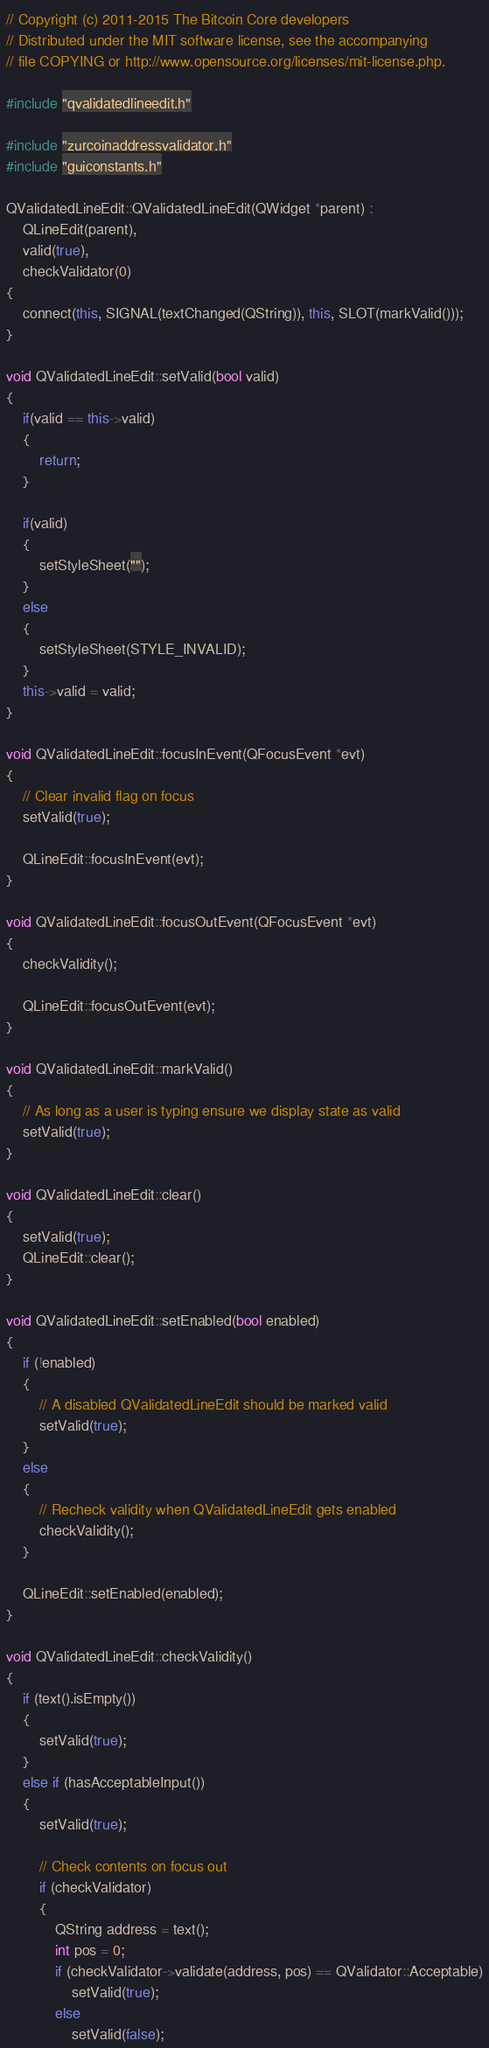Convert code to text. <code><loc_0><loc_0><loc_500><loc_500><_C++_>// Copyright (c) 2011-2015 The Bitcoin Core developers
// Distributed under the MIT software license, see the accompanying
// file COPYING or http://www.opensource.org/licenses/mit-license.php.

#include "qvalidatedlineedit.h"

#include "zurcoinaddressvalidator.h"
#include "guiconstants.h"

QValidatedLineEdit::QValidatedLineEdit(QWidget *parent) :
    QLineEdit(parent),
    valid(true),
    checkValidator(0)
{
    connect(this, SIGNAL(textChanged(QString)), this, SLOT(markValid()));
}

void QValidatedLineEdit::setValid(bool valid)
{
    if(valid == this->valid)
    {
        return;
    }

    if(valid)
    {
        setStyleSheet("");
    }
    else
    {
        setStyleSheet(STYLE_INVALID);
    }
    this->valid = valid;
}

void QValidatedLineEdit::focusInEvent(QFocusEvent *evt)
{
    // Clear invalid flag on focus
    setValid(true);

    QLineEdit::focusInEvent(evt);
}

void QValidatedLineEdit::focusOutEvent(QFocusEvent *evt)
{
    checkValidity();

    QLineEdit::focusOutEvent(evt);
}

void QValidatedLineEdit::markValid()
{
    // As long as a user is typing ensure we display state as valid
    setValid(true);
}

void QValidatedLineEdit::clear()
{
    setValid(true);
    QLineEdit::clear();
}

void QValidatedLineEdit::setEnabled(bool enabled)
{
    if (!enabled)
    {
        // A disabled QValidatedLineEdit should be marked valid
        setValid(true);
    }
    else
    {
        // Recheck validity when QValidatedLineEdit gets enabled
        checkValidity();
    }

    QLineEdit::setEnabled(enabled);
}

void QValidatedLineEdit::checkValidity()
{
    if (text().isEmpty())
    {
        setValid(true);
    }
    else if (hasAcceptableInput())
    {
        setValid(true);

        // Check contents on focus out
        if (checkValidator)
        {
            QString address = text();
            int pos = 0;
            if (checkValidator->validate(address, pos) == QValidator::Acceptable)
                setValid(true);
            else
                setValid(false);</code> 